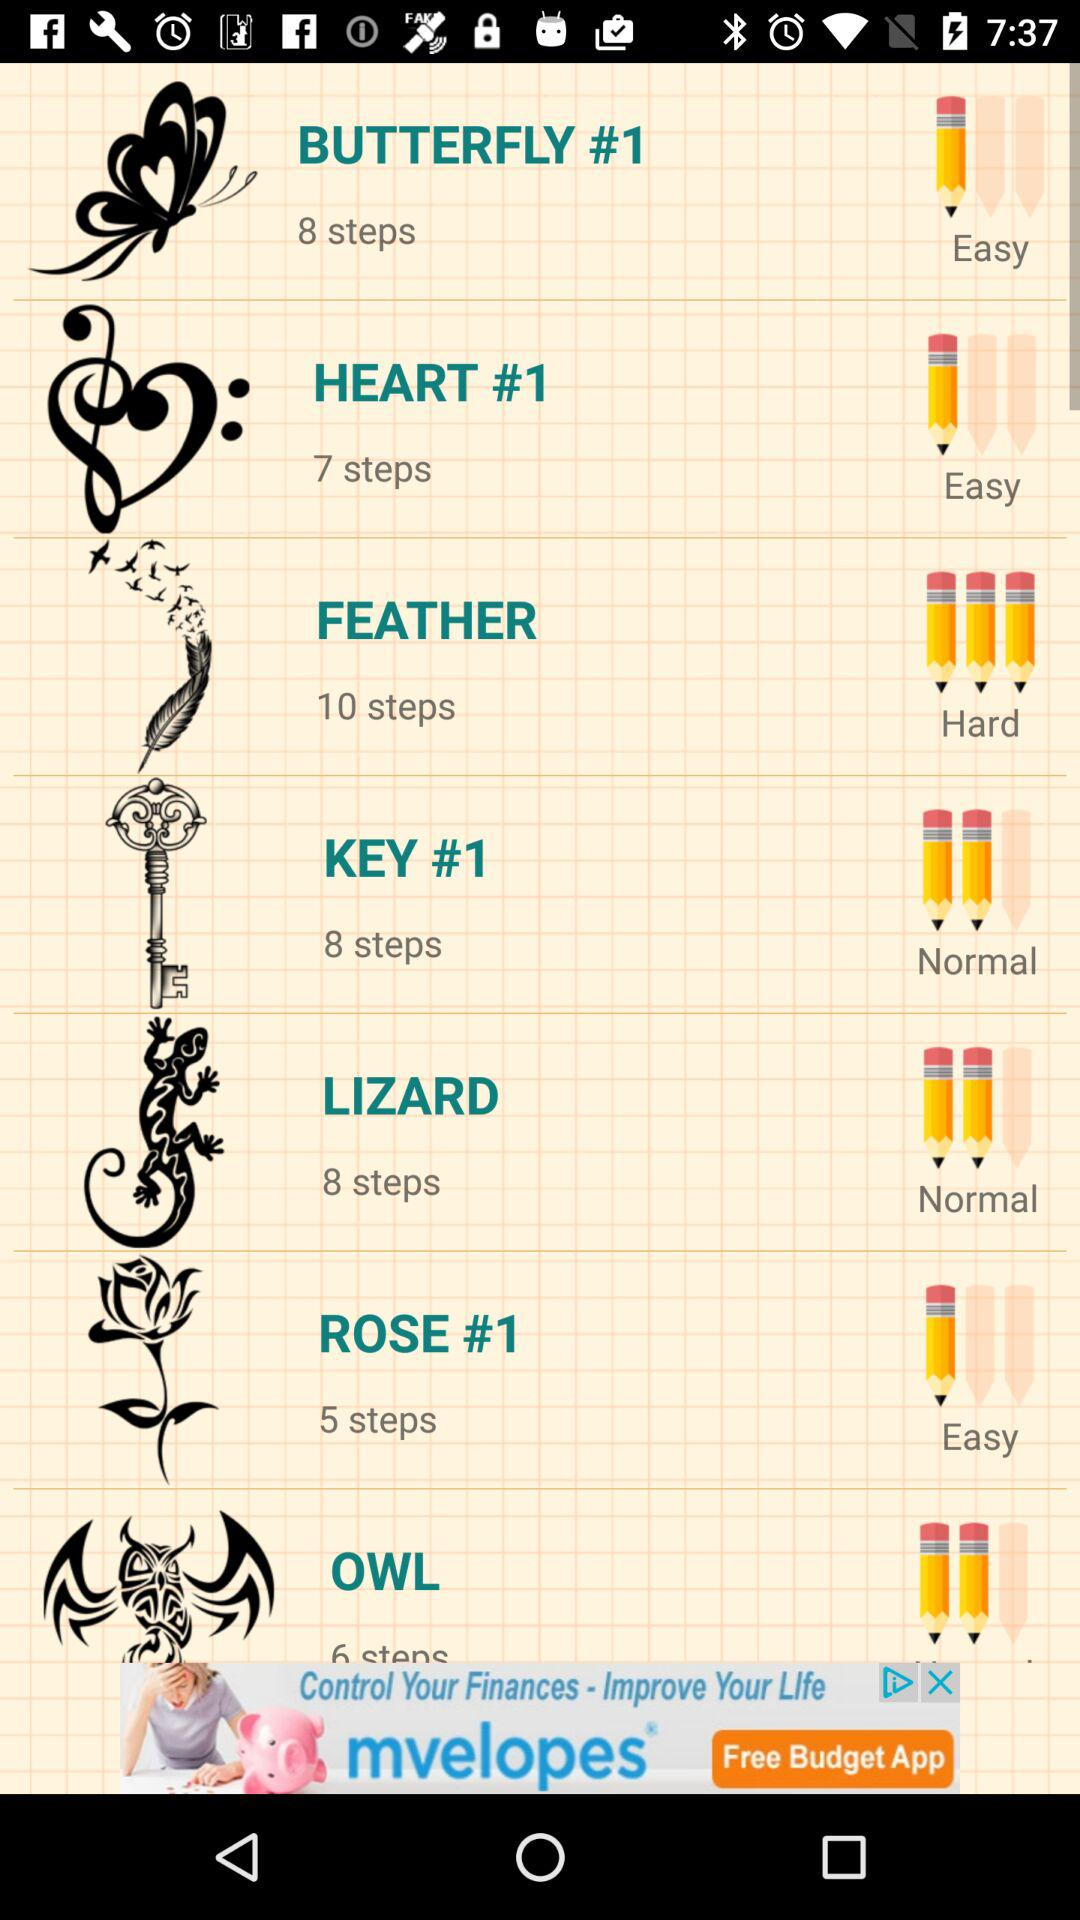How many steps for the Lizard? There are 8 steps. 